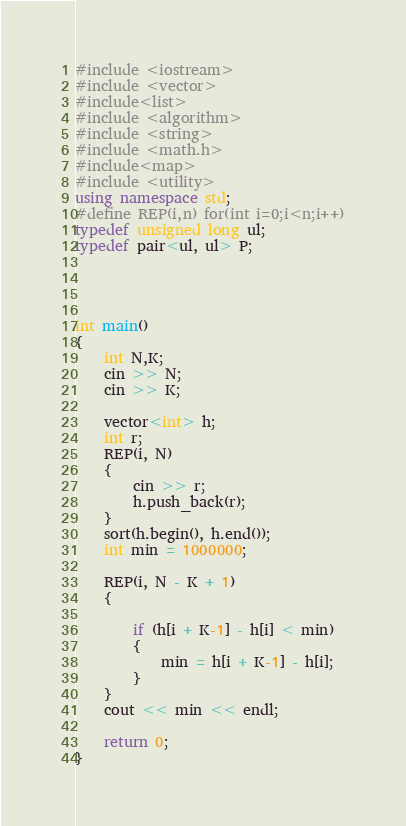<code> <loc_0><loc_0><loc_500><loc_500><_C++_>#include <iostream>
#include <vector>
#include<list>
#include <algorithm>
#include <string>
#include <math.h>
#include<map>
#include <utility>
using namespace std;
#define REP(i,n) for(int i=0;i<n;i++)
typedef unsigned long ul;
typedef pair<ul, ul> P;




int main()
{
    int N,K;
    cin >> N;
	cin >> K;

	vector<int> h;
	int r;
	REP(i, N)
	{
		cin >> r;
		h.push_back(r);
	}
	sort(h.begin(), h.end());
	int min = 1000000;
	
	REP(i, N - K + 1)
	{
		
		if (h[i + K-1] - h[i] < min)
		{
			min = h[i + K-1] - h[i];
		}
	}
	cout << min << endl;

	return 0;
}</code> 